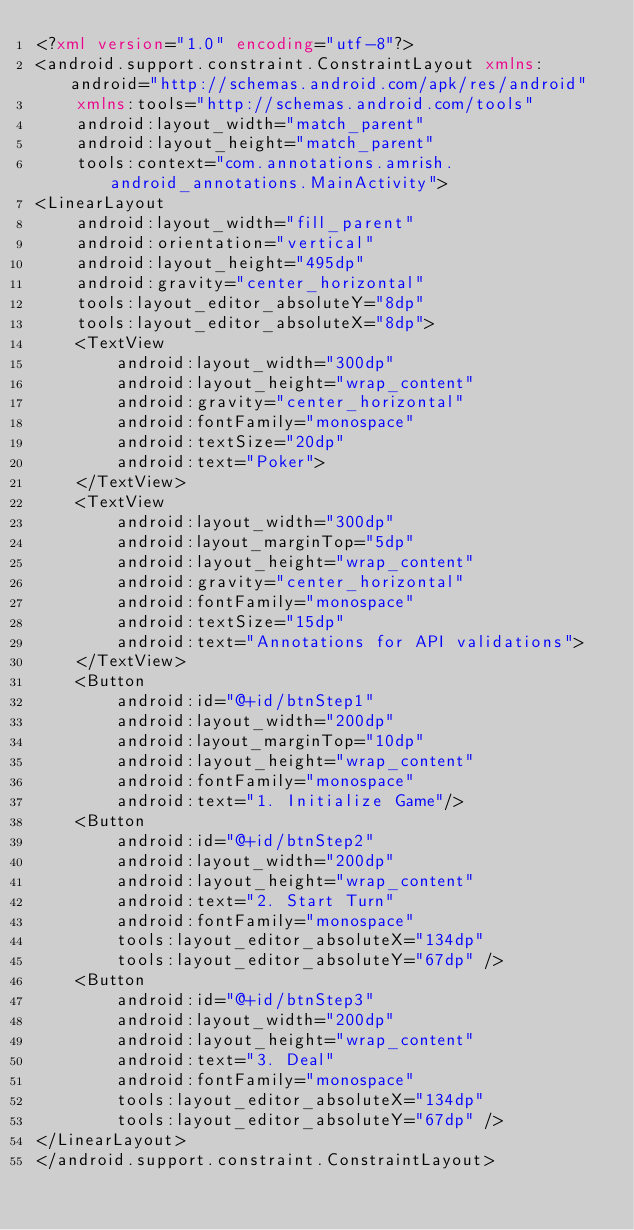<code> <loc_0><loc_0><loc_500><loc_500><_XML_><?xml version="1.0" encoding="utf-8"?>
<android.support.constraint.ConstraintLayout xmlns:android="http://schemas.android.com/apk/res/android"
    xmlns:tools="http://schemas.android.com/tools"
    android:layout_width="match_parent"
    android:layout_height="match_parent"
    tools:context="com.annotations.amrish.android_annotations.MainActivity">
<LinearLayout
    android:layout_width="fill_parent"
    android:orientation="vertical"
    android:layout_height="495dp"
    android:gravity="center_horizontal"
    tools:layout_editor_absoluteY="8dp"
    tools:layout_editor_absoluteX="8dp">
    <TextView
        android:layout_width="300dp"
        android:layout_height="wrap_content"
        android:gravity="center_horizontal"
        android:fontFamily="monospace"
        android:textSize="20dp"
        android:text="Poker">
    </TextView>
    <TextView
        android:layout_width="300dp"
        android:layout_marginTop="5dp"
        android:layout_height="wrap_content"
        android:gravity="center_horizontal"
        android:fontFamily="monospace"
        android:textSize="15dp"
        android:text="Annotations for API validations">
    </TextView>
    <Button
        android:id="@+id/btnStep1"
        android:layout_width="200dp"
        android:layout_marginTop="10dp"
        android:layout_height="wrap_content"
        android:fontFamily="monospace"
        android:text="1. Initialize Game"/>
    <Button
        android:id="@+id/btnStep2"
        android:layout_width="200dp"
        android:layout_height="wrap_content"
        android:text="2. Start Turn"
        android:fontFamily="monospace"
        tools:layout_editor_absoluteX="134dp"
        tools:layout_editor_absoluteY="67dp" />
    <Button
        android:id="@+id/btnStep3"
        android:layout_width="200dp"
        android:layout_height="wrap_content"
        android:text="3. Deal"
        android:fontFamily="monospace"
        tools:layout_editor_absoluteX="134dp"
        tools:layout_editor_absoluteY="67dp" />
</LinearLayout>
</android.support.constraint.ConstraintLayout>
</code> 